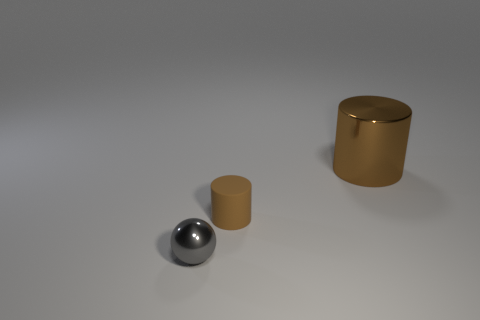Subtract all blue cylinders. Subtract all gray balls. How many cylinders are left? 2 Add 1 matte objects. How many objects exist? 4 Subtract all cylinders. How many objects are left? 1 Subtract 0 blue cylinders. How many objects are left? 3 Subtract all metal cylinders. Subtract all tiny gray metallic balls. How many objects are left? 1 Add 2 tiny gray objects. How many tiny gray objects are left? 3 Add 1 green balls. How many green balls exist? 1 